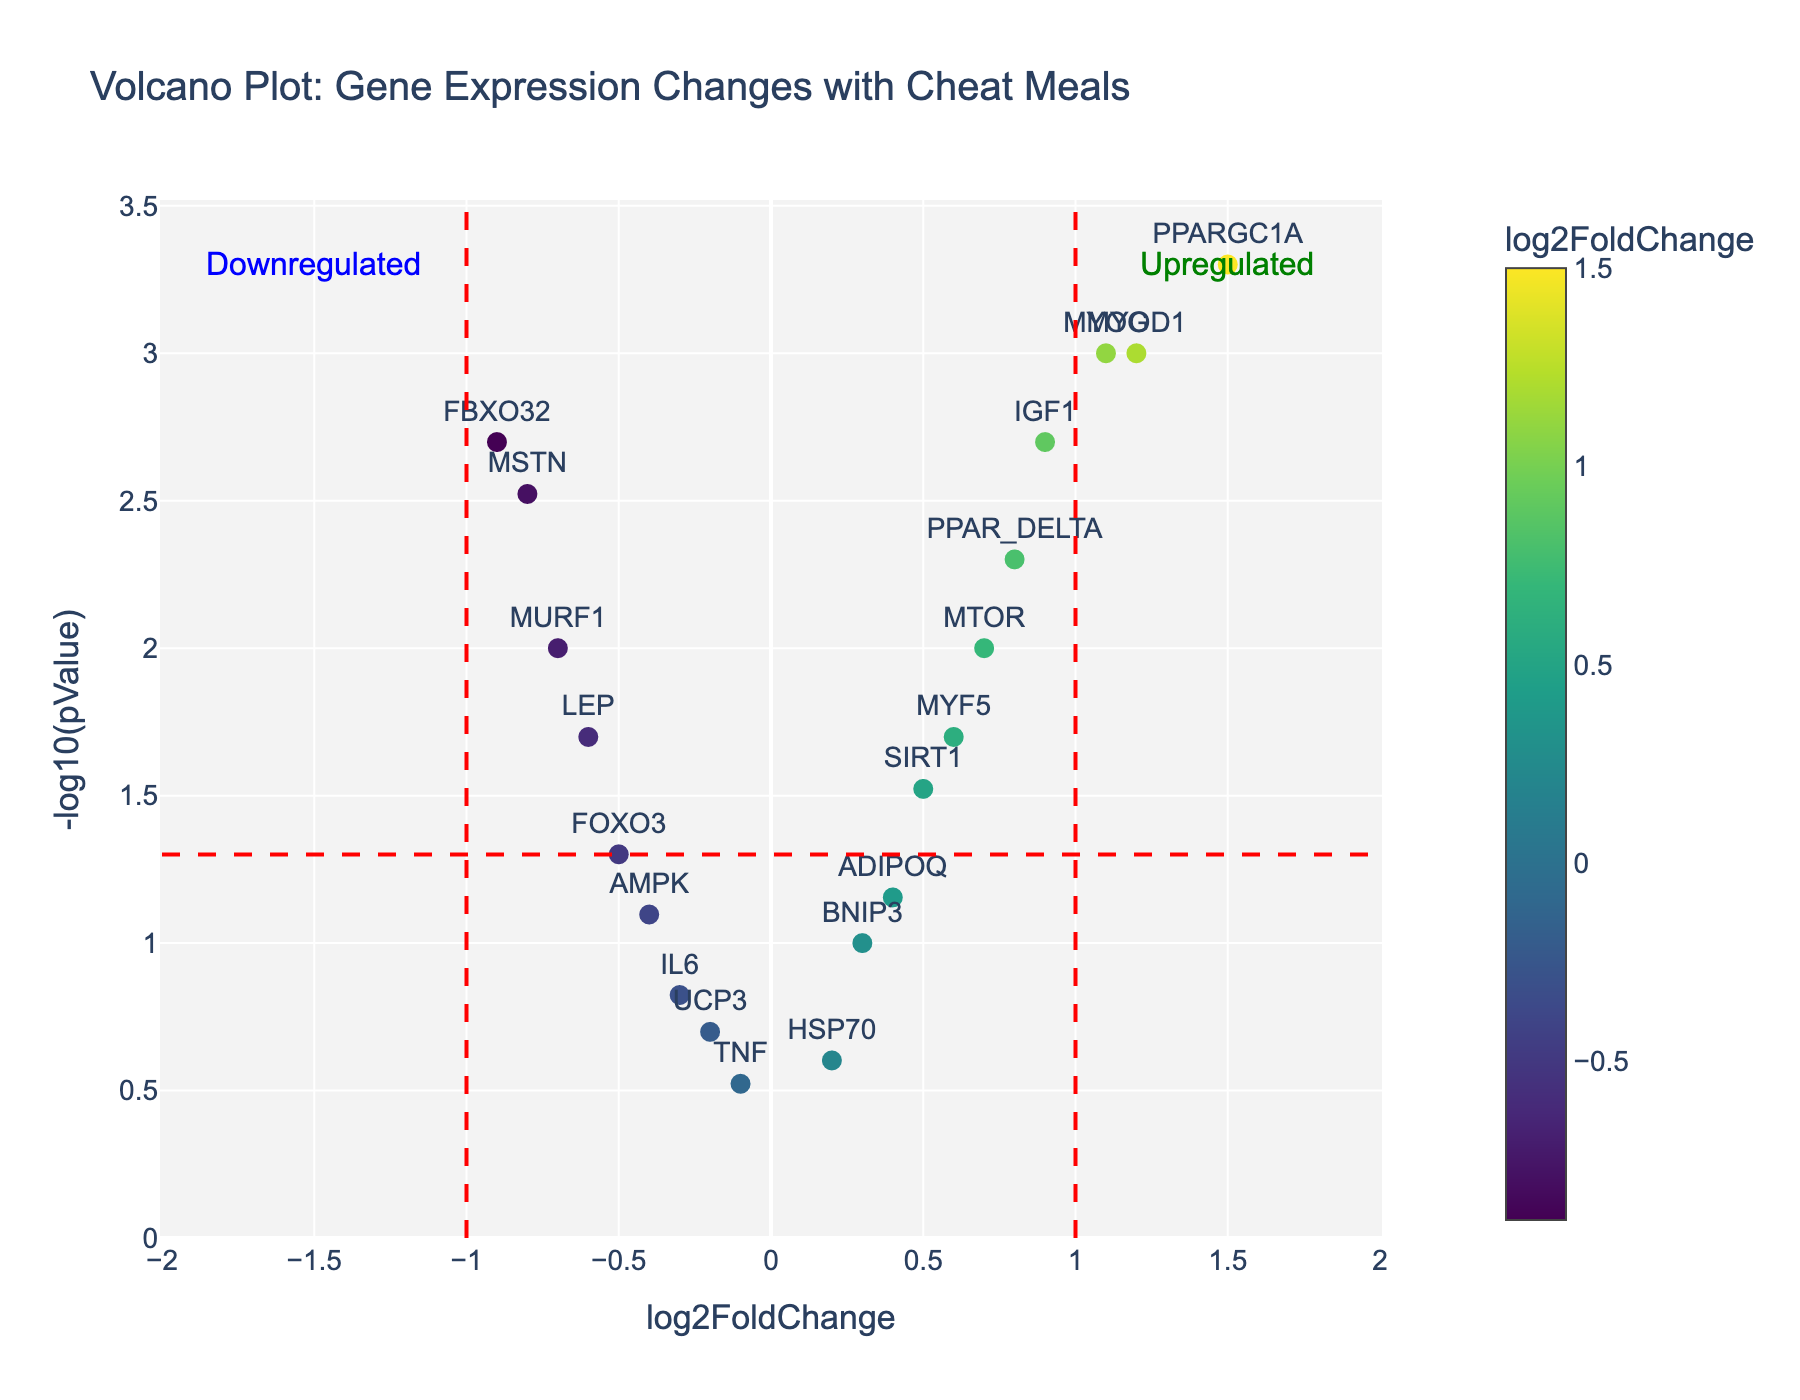What's the title of the figure? The title is usually at the top of the figure. In this case, it can be seen as "Volcano Plot: Gene Expression Changes with Cheat Meals."
Answer: "Volcano Plot: Gene Expression Changes with Cheat Meals" What's on the x-axis and y-axis? The x-axis shows "log2FoldChange" and the y-axis shows "-log10(pValue)." These are common elements in volcano plots which measure gene expression changes and the significance of these changes, respectively.
Answer: log2FoldChange on x-axis, -log10(pValue) on y-axis How is the point for MYOD1 characterized in terms of fold change and p-value? MYOD1 has a log2FoldChange of 1.2 and a pValue of 0.001. The -log10(pValue) calculation gives -log10(0.001) which is 3.
Answer: log2FoldChange: 1.2, -log10(pValue): 3 Are there any genes that are significantly downregulated based on the plot thresholds? Genes significantly downregulated would be to the left of the x= -1 threshold and above the y=1.3 threshold. Here, FBXO32 and MSTN fit this description.
Answer: FBXO32, MSTN Which gene has the highest log2FoldChange? The highest log2FoldChange can be found by identifying the data point farthest to the right on the x-axis. This is PPARGC1A with a log2FoldChange of 1.5.
Answer: PPARGC1A How many genes have a p-value indicating statistical significance? Visually, genes with statistical significance would be above the y=1.3 (equivalent to -log10 of 0.05) threshold. This includes MYOD1, IGF1, PPARGC1A, MYOG, PPAR_DELTA, MSTN, FBXO32, and LEP. Counting these gives 8 genes.
Answer: 8 genes Which genes are neither upregulated nor downregulated significantly? Genes that are not significantly up- or downregulated would be between the x = -1 and x = 1 lines and below the y = 1.3 line. This includes BNIP3, UCP3, IL6, TNF, HSP70
Answer: BNIP3, UCP3, IL6, TNF, HSP70 Do any genes show a log2FoldChange exactly equal to 1 or -1? To find this, we look along the x-axis lines drawn at x = -1 and x = 1. None of the data points lie exactly on these lines.
Answer: No Which gene has the highest p-value, and what is its corresponding -log10(p-value)? The highest p-value will have the lowest corresponding -log10(pValue). Here, TNF has the highest p-value of 0.3, so the -log10(pValue) is -log10(0.3) which is approximately 0.52.
Answer: TNF, -log10(pValue): 0.52 